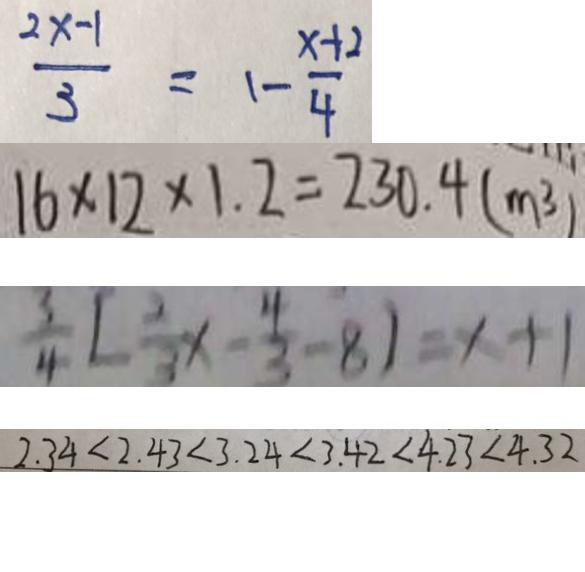<formula> <loc_0><loc_0><loc_500><loc_500>\frac { 2 x - 1 } { 3 } = 1 - \frac { x + 2 } { 4 } 
 1 6 \times 1 2 \times 1 . 2 = 2 3 0 . 4 ( m ^ { 3 } ) 
 \frac { 3 } { 4 } [ \frac { 2 } { 3 } x - \frac { 4 } { 3 } - 8 ] = x + 1 
 2 . 3 4 < 2 . 4 3 < 3 . 2 4 < 3 . 4 2 < 4 . 2 3 < 4 . 3 2</formula> 